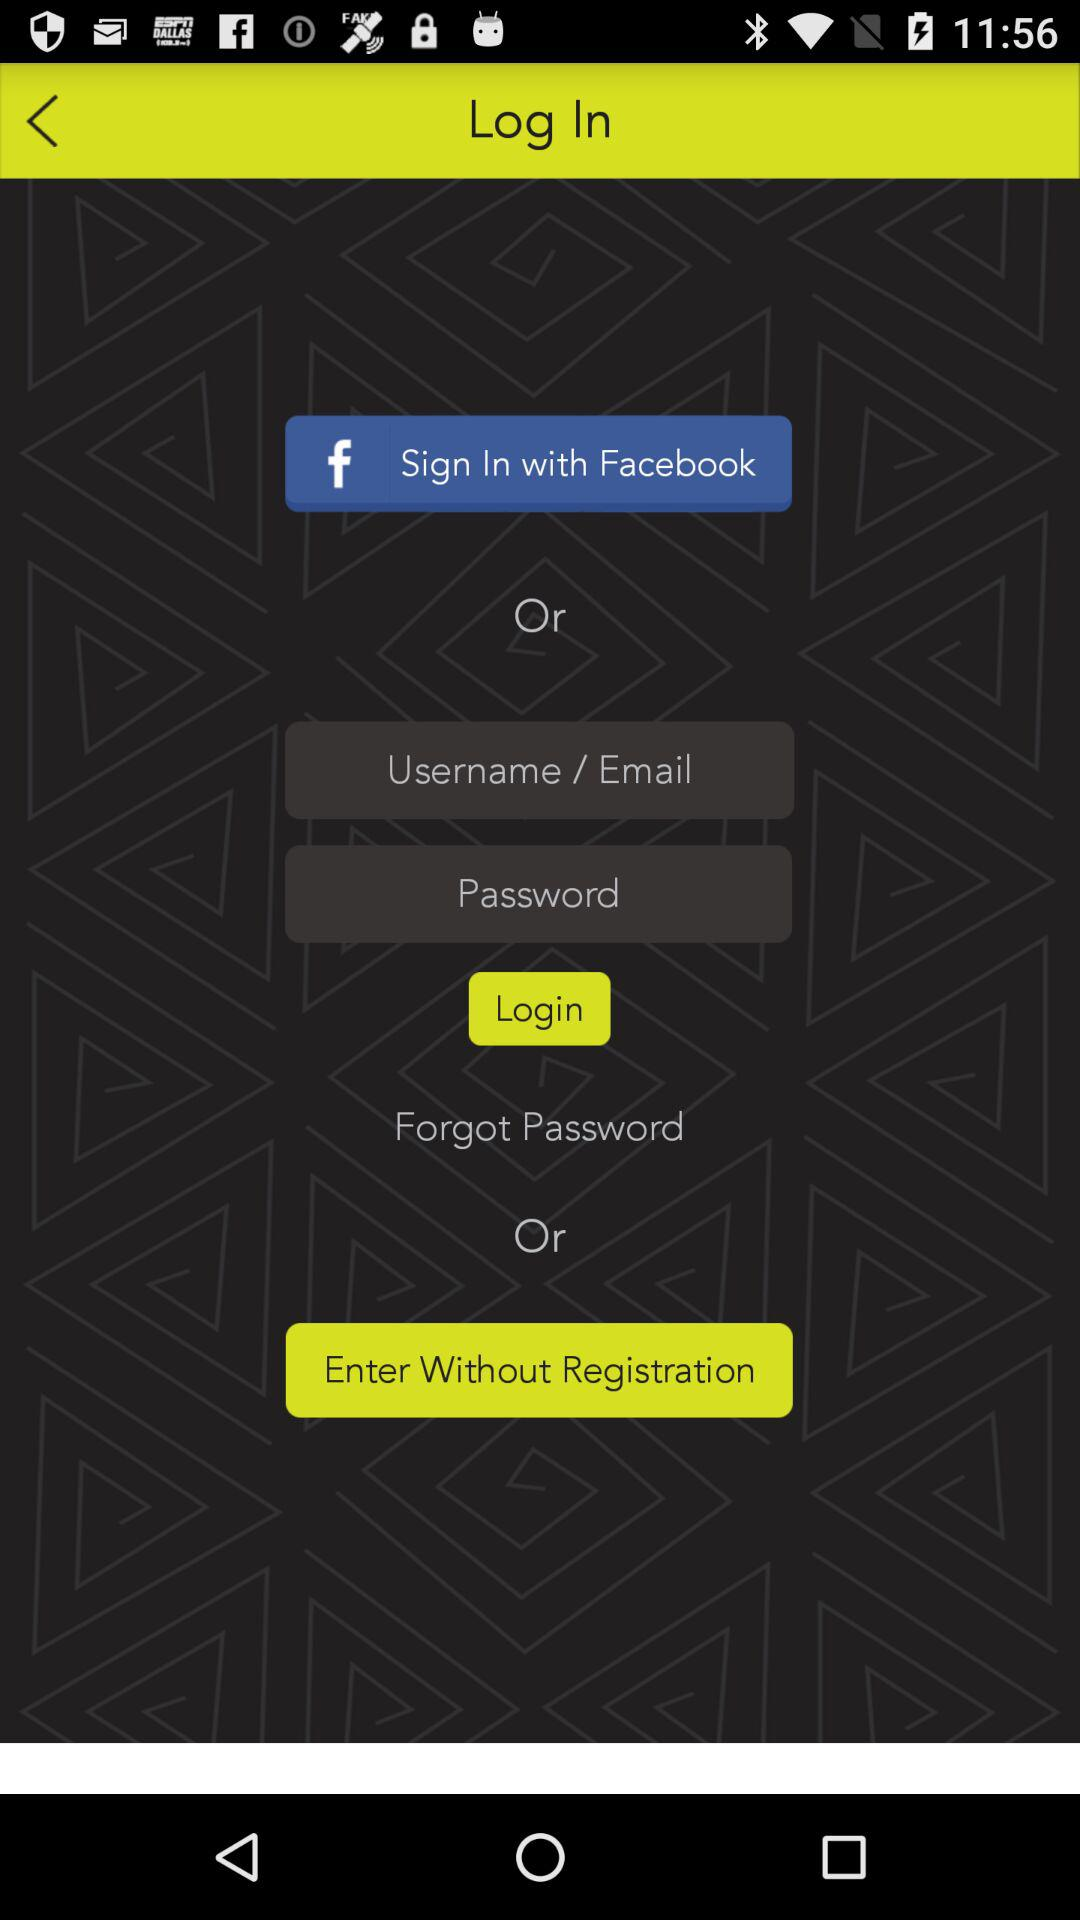What are the options given for logging in? The given options are "Facebook" and "Username / Email". 